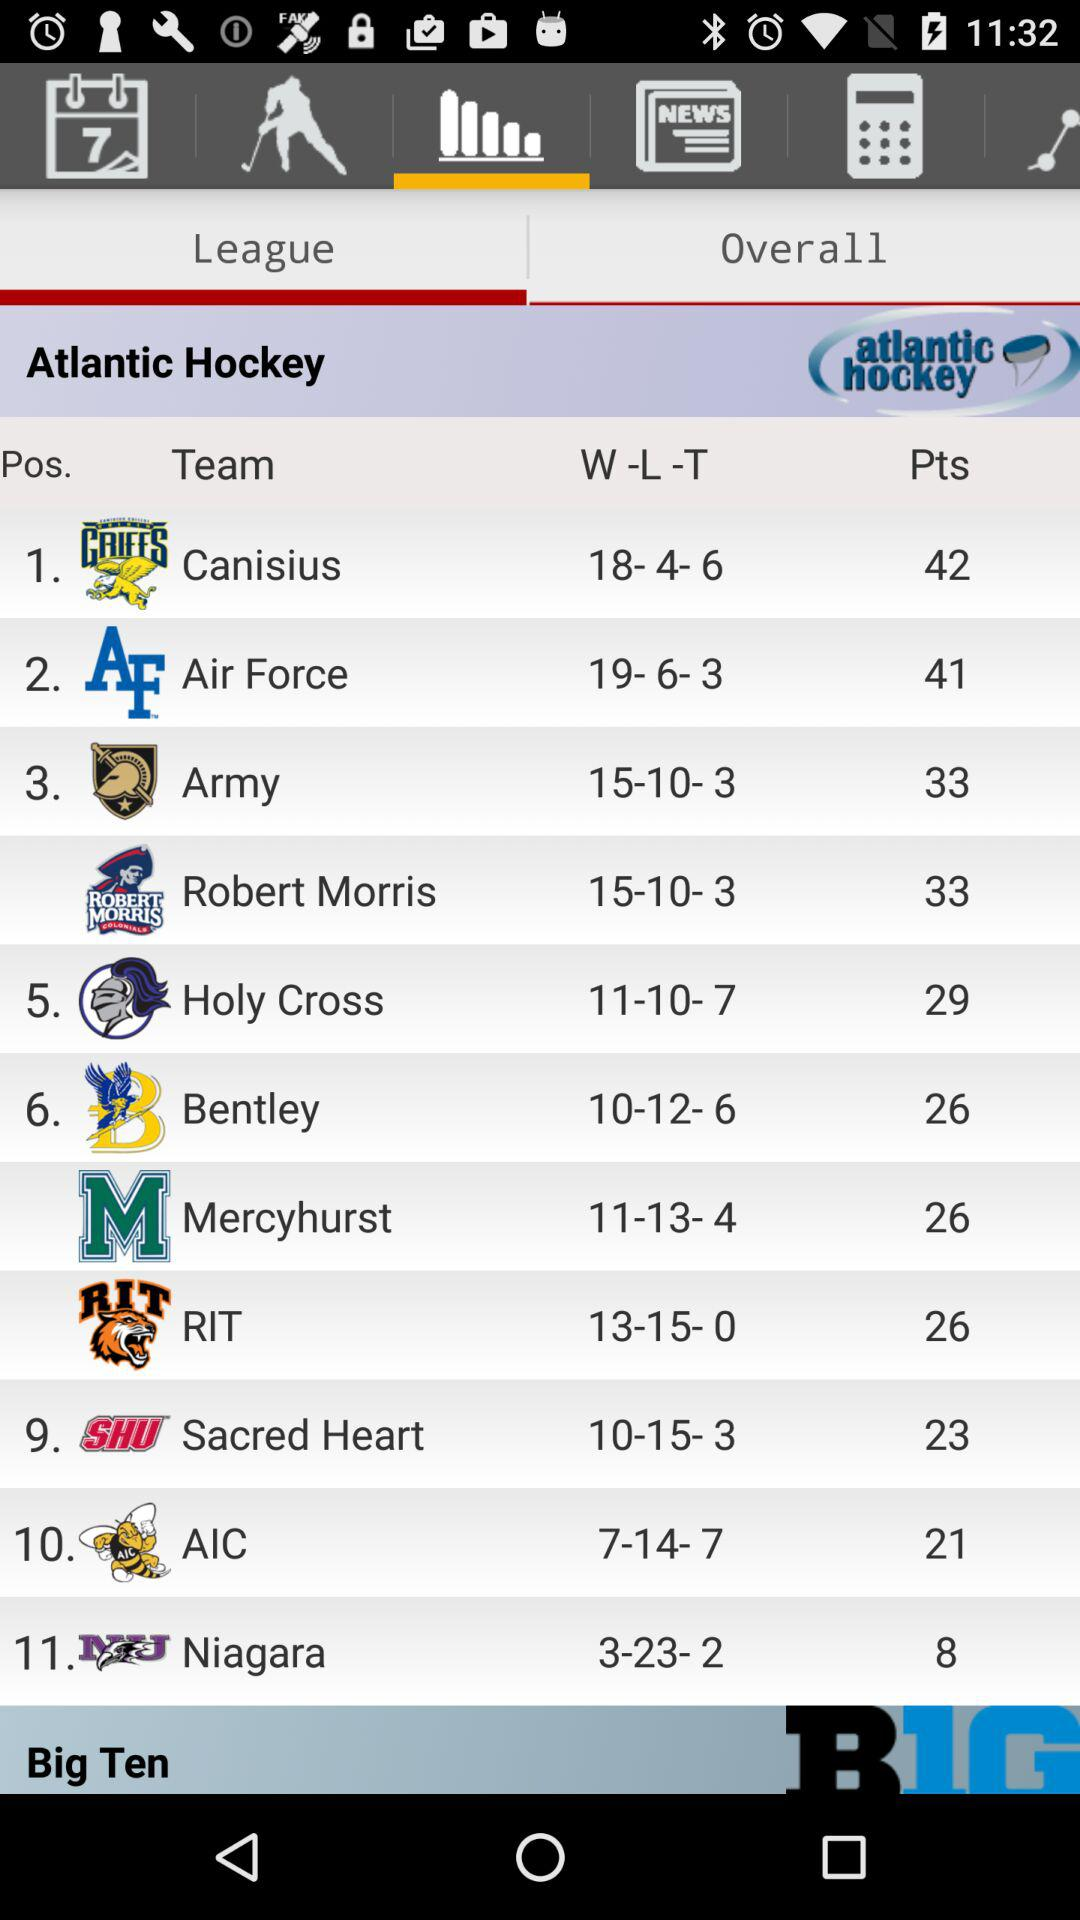What are the points of the Army team in the Atlantic Hockey League? The points are 33. 